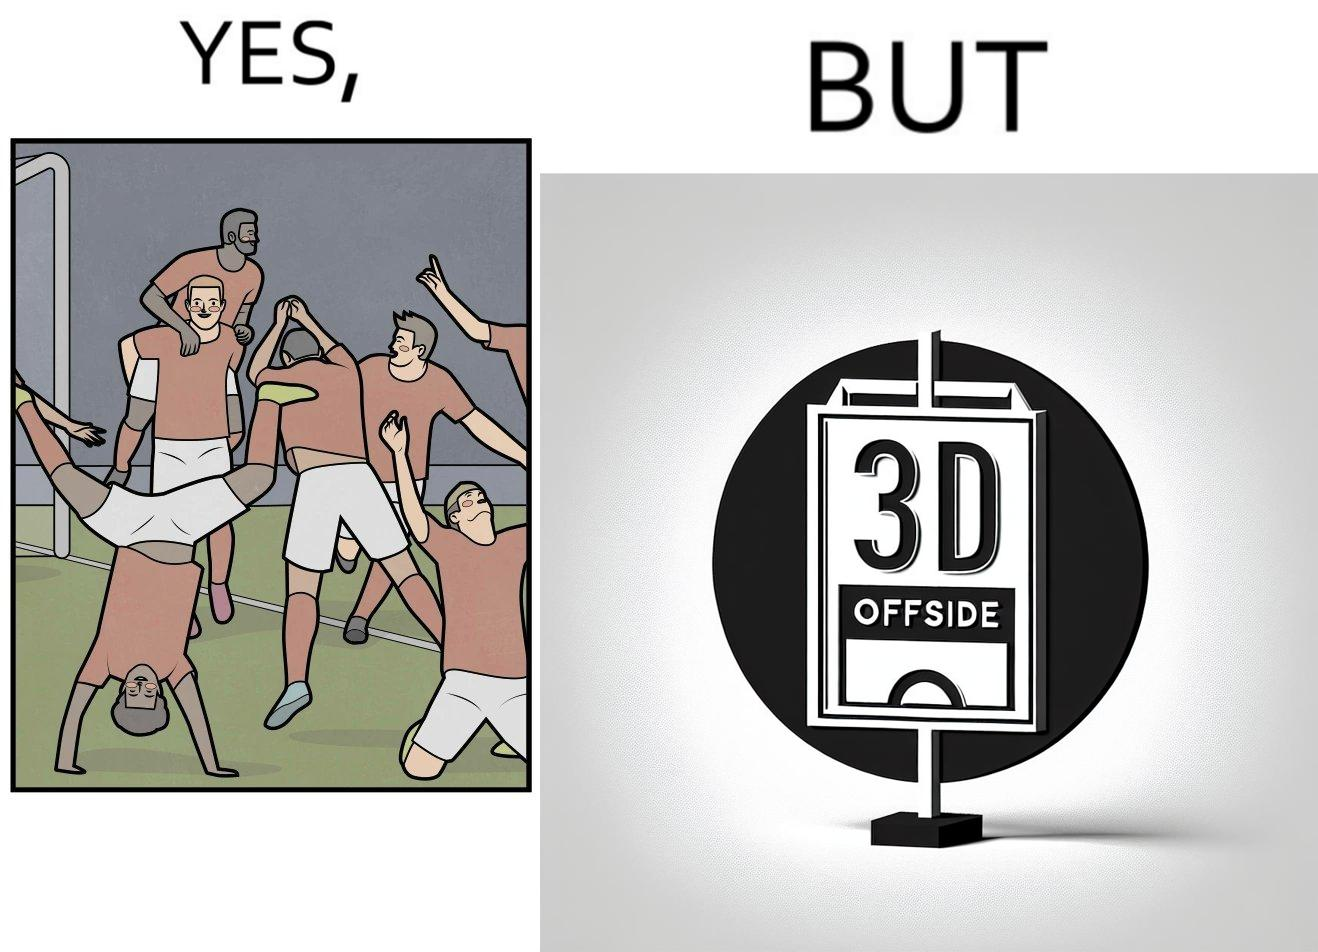Describe the contrast between the left and right parts of this image. In the left part of the image: football players celebrating, probably due a goal their team has scored. In the right part of the image: A sign of "No goal - Offside". 